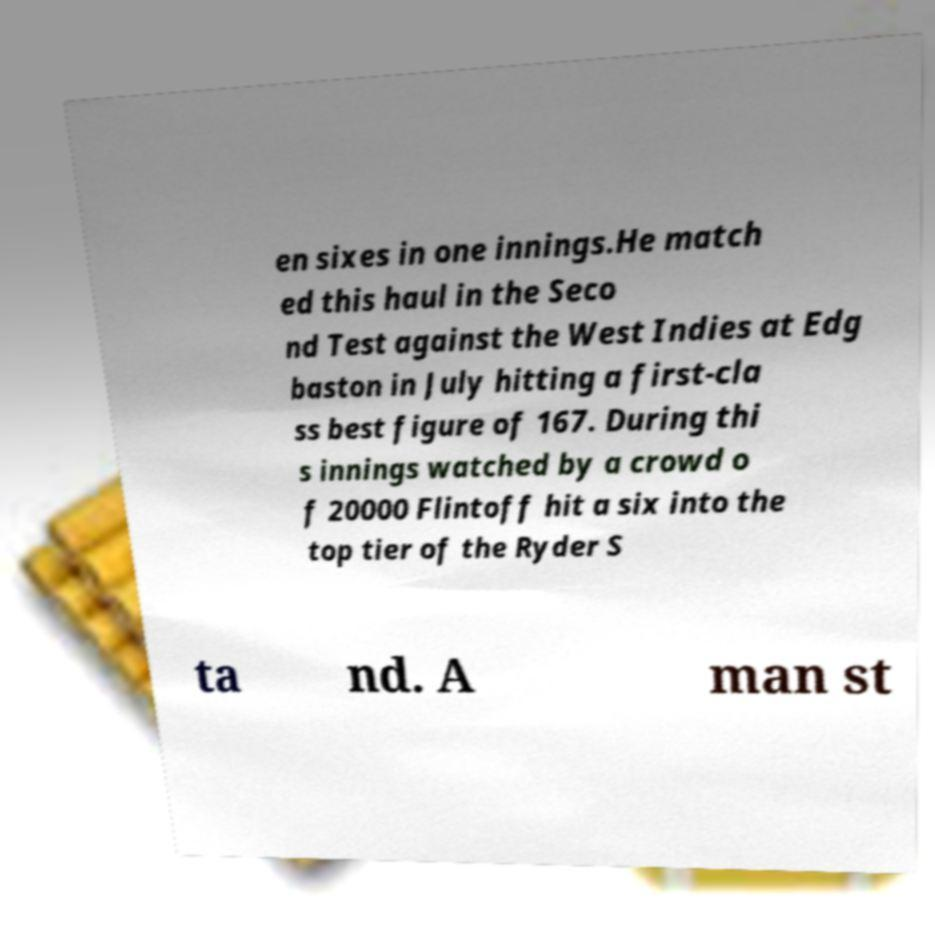Please read and relay the text visible in this image. What does it say? en sixes in one innings.He match ed this haul in the Seco nd Test against the West Indies at Edg baston in July hitting a first-cla ss best figure of 167. During thi s innings watched by a crowd o f 20000 Flintoff hit a six into the top tier of the Ryder S ta nd. A man st 